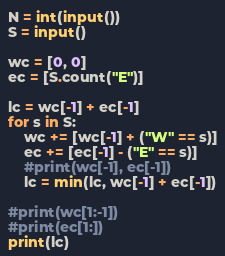Convert code to text. <code><loc_0><loc_0><loc_500><loc_500><_Python_>N = int(input())
S = input()

wc = [0, 0]
ec = [S.count("E")]

lc = wc[-1] + ec[-1]
for s in S:
	wc += [wc[-1] + ("W" == s)]
	ec += [ec[-1] - ("E" == s)]
	#print(wc[-1], ec[-1])
	lc = min(lc, wc[-1] + ec[-1])

#print(wc[1:-1])
#print(ec[1:])
print(lc)
</code> 